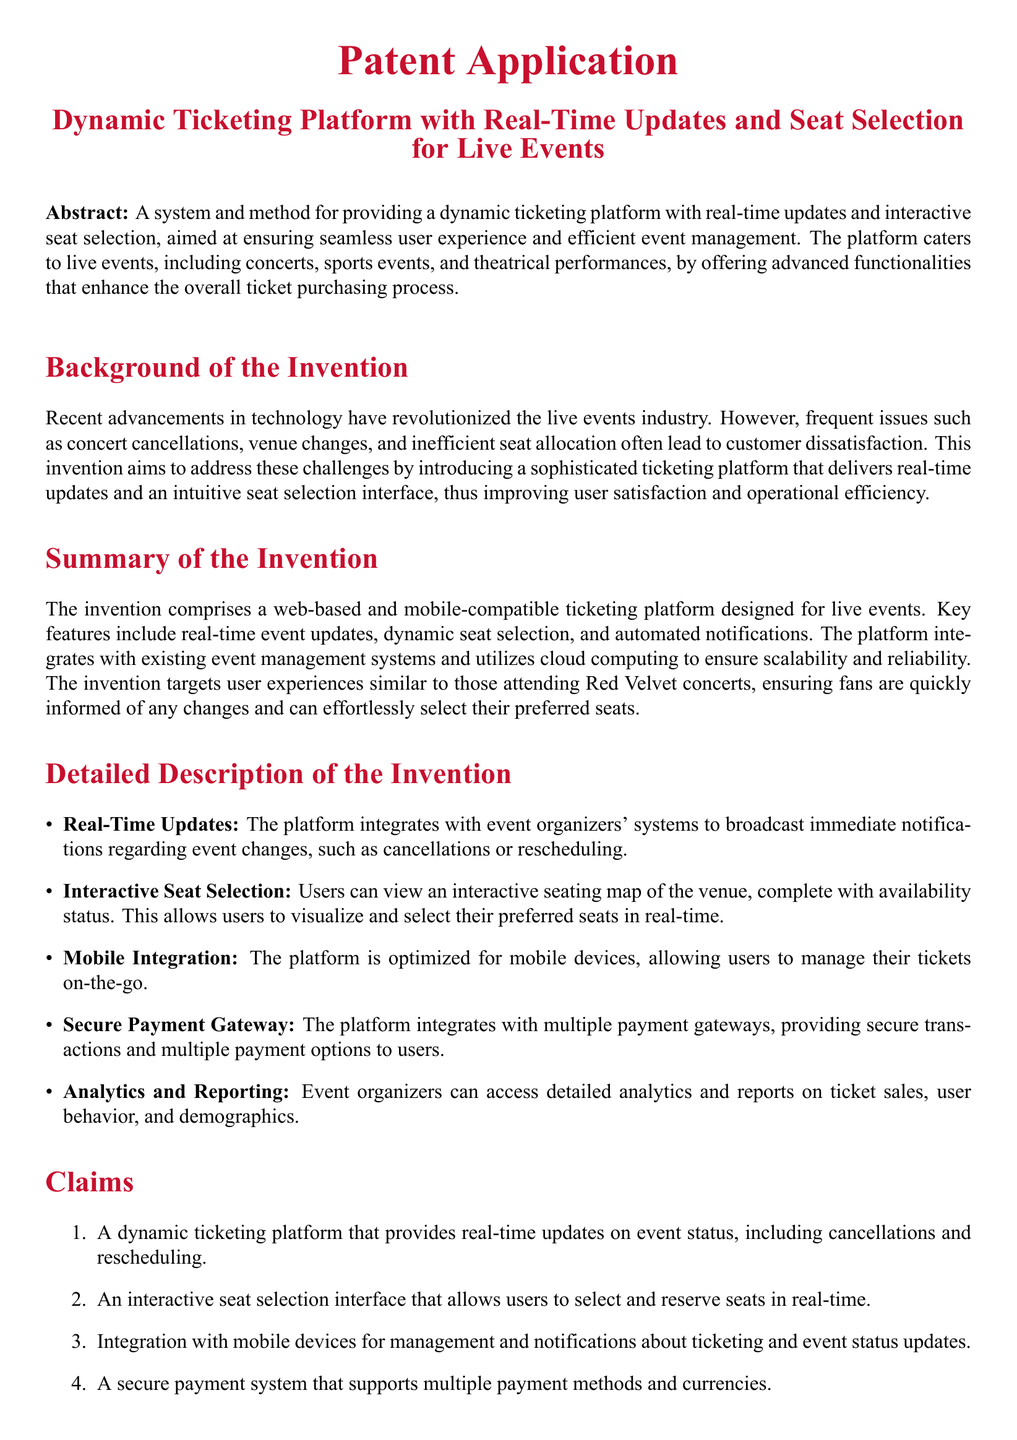What is the main purpose of the invention? The main purpose of the invention is to provide a dynamic ticketing platform with real-time updates and interactive seat selection for live events.
Answer: Dynamic ticketing platform with real-time updates and interactive seat selection for live events What are two key features of the platform? Two key features of the platform are real-time updates and interactive seat selection.
Answer: Real-time updates and interactive seat selection How does the platform ensure user satisfaction? The platform ensures user satisfaction by delivering real-time updates and an intuitive seat selection interface.
Answer: Real-time updates and an intuitive seat selection interface What type of events does the platform cater to? The platform caters to live events, including concerts, sports events, and theatrical performances.
Answer: Live events, including concerts, sports events, and theatrical performances Is the platform mobile-compatible? Yes, the platform is optimized for mobile devices.
Answer: Yes What does the analytics and reporting feature provide? The analytics and reporting feature provides detailed analytics and reports on ticket sales, user behavior, and demographics.
Answer: Detailed analytics and reports on ticket sales, user behavior, and demographics How many claims are listed in the patent application? There are five claims listed in the patent application.
Answer: Five What is the significance of the secure payment gateway? The secure payment gateway allows for secure transactions and multiple payment options for users.
Answer: Secure transactions and multiple payment options for users What technology does the platform utilize for scalability? The platform utilizes cloud computing to ensure scalability and reliability.
Answer: Cloud computing 